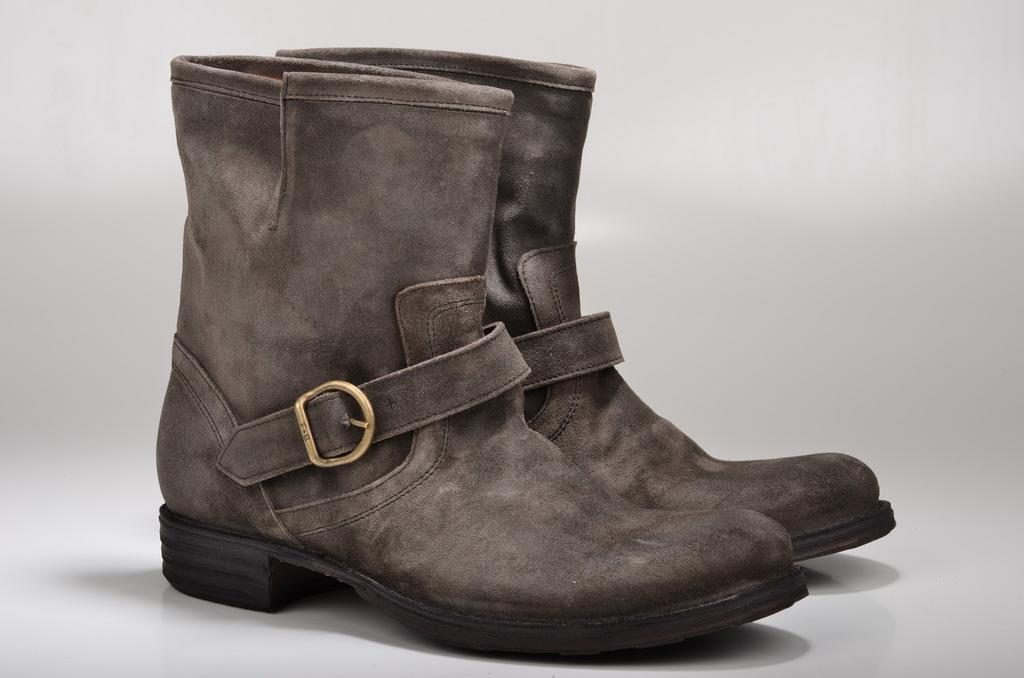What type of footwear is present in the image? There are two boots in the image. What accessory can be seen in the image? There is a belt in the image. What type of cemetery is visible in the image? There is no cemetery present in the image; it only features two boots and a belt. Who is the creator of the boots and belt in the image? The image does not provide information about the creator of the boots and belt. 